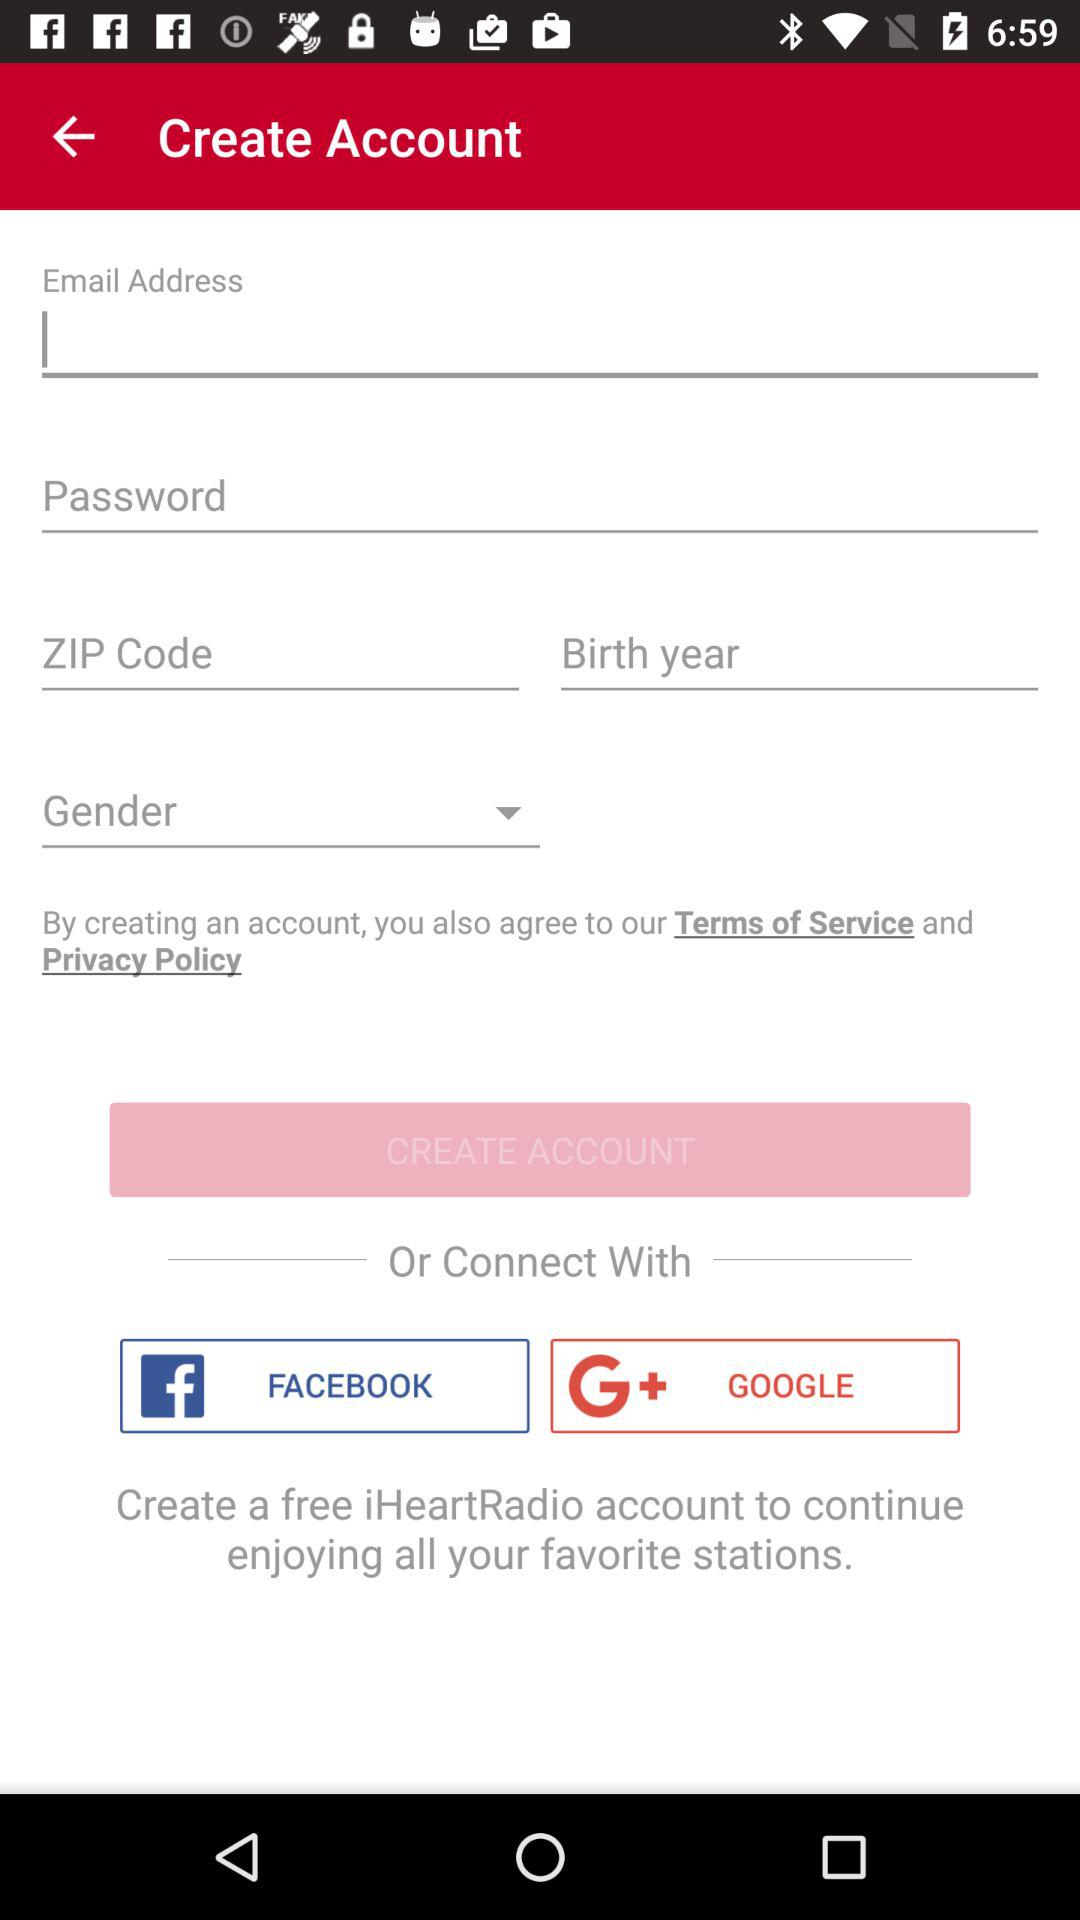What is the name of the application? The name of the application is "iHeartRadio". 